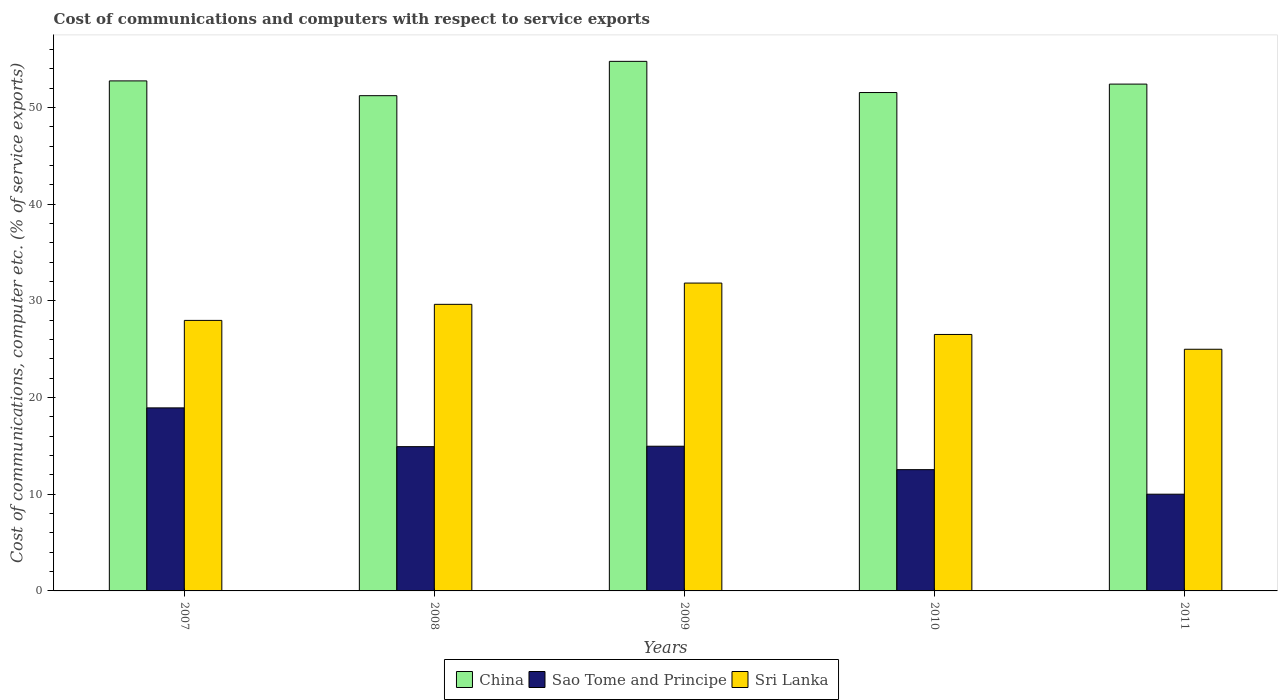How many groups of bars are there?
Your response must be concise. 5. What is the cost of communications and computers in China in 2011?
Offer a very short reply. 52.43. Across all years, what is the maximum cost of communications and computers in Sri Lanka?
Make the answer very short. 31.84. Across all years, what is the minimum cost of communications and computers in Sao Tome and Principe?
Offer a very short reply. 10. In which year was the cost of communications and computers in Sri Lanka minimum?
Your answer should be very brief. 2011. What is the total cost of communications and computers in China in the graph?
Offer a very short reply. 262.74. What is the difference between the cost of communications and computers in Sri Lanka in 2008 and that in 2010?
Provide a succinct answer. 3.12. What is the difference between the cost of communications and computers in Sao Tome and Principe in 2007 and the cost of communications and computers in China in 2008?
Make the answer very short. -32.29. What is the average cost of communications and computers in Sri Lanka per year?
Make the answer very short. 28.2. In the year 2010, what is the difference between the cost of communications and computers in Sri Lanka and cost of communications and computers in Sao Tome and Principe?
Make the answer very short. 13.98. In how many years, is the cost of communications and computers in Sao Tome and Principe greater than 52 %?
Give a very brief answer. 0. What is the ratio of the cost of communications and computers in China in 2009 to that in 2011?
Provide a succinct answer. 1.04. Is the cost of communications and computers in China in 2008 less than that in 2009?
Provide a short and direct response. Yes. What is the difference between the highest and the second highest cost of communications and computers in Sao Tome and Principe?
Give a very brief answer. 3.97. What is the difference between the highest and the lowest cost of communications and computers in Sri Lanka?
Provide a short and direct response. 6.85. In how many years, is the cost of communications and computers in Sri Lanka greater than the average cost of communications and computers in Sri Lanka taken over all years?
Give a very brief answer. 2. Is the sum of the cost of communications and computers in China in 2007 and 2009 greater than the maximum cost of communications and computers in Sri Lanka across all years?
Your response must be concise. Yes. What does the 3rd bar from the left in 2010 represents?
Keep it short and to the point. Sri Lanka. What does the 2nd bar from the right in 2009 represents?
Your answer should be very brief. Sao Tome and Principe. How many bars are there?
Make the answer very short. 15. Are the values on the major ticks of Y-axis written in scientific E-notation?
Make the answer very short. No. What is the title of the graph?
Your response must be concise. Cost of communications and computers with respect to service exports. Does "Argentina" appear as one of the legend labels in the graph?
Make the answer very short. No. What is the label or title of the X-axis?
Keep it short and to the point. Years. What is the label or title of the Y-axis?
Provide a succinct answer. Cost of communications, computer etc. (% of service exports). What is the Cost of communications, computer etc. (% of service exports) of China in 2007?
Provide a succinct answer. 52.76. What is the Cost of communications, computer etc. (% of service exports) in Sao Tome and Principe in 2007?
Make the answer very short. 18.93. What is the Cost of communications, computer etc. (% of service exports) in Sri Lanka in 2007?
Your answer should be very brief. 27.98. What is the Cost of communications, computer etc. (% of service exports) in China in 2008?
Make the answer very short. 51.23. What is the Cost of communications, computer etc. (% of service exports) in Sao Tome and Principe in 2008?
Provide a short and direct response. 14.92. What is the Cost of communications, computer etc. (% of service exports) in Sri Lanka in 2008?
Offer a very short reply. 29.64. What is the Cost of communications, computer etc. (% of service exports) in China in 2009?
Keep it short and to the point. 54.78. What is the Cost of communications, computer etc. (% of service exports) of Sao Tome and Principe in 2009?
Provide a short and direct response. 14.97. What is the Cost of communications, computer etc. (% of service exports) of Sri Lanka in 2009?
Your response must be concise. 31.84. What is the Cost of communications, computer etc. (% of service exports) in China in 2010?
Offer a very short reply. 51.55. What is the Cost of communications, computer etc. (% of service exports) of Sao Tome and Principe in 2010?
Offer a very short reply. 12.54. What is the Cost of communications, computer etc. (% of service exports) of Sri Lanka in 2010?
Make the answer very short. 26.53. What is the Cost of communications, computer etc. (% of service exports) of China in 2011?
Give a very brief answer. 52.43. What is the Cost of communications, computer etc. (% of service exports) of Sao Tome and Principe in 2011?
Ensure brevity in your answer.  10. What is the Cost of communications, computer etc. (% of service exports) of Sri Lanka in 2011?
Your answer should be compact. 25. Across all years, what is the maximum Cost of communications, computer etc. (% of service exports) of China?
Your answer should be very brief. 54.78. Across all years, what is the maximum Cost of communications, computer etc. (% of service exports) in Sao Tome and Principe?
Keep it short and to the point. 18.93. Across all years, what is the maximum Cost of communications, computer etc. (% of service exports) of Sri Lanka?
Offer a terse response. 31.84. Across all years, what is the minimum Cost of communications, computer etc. (% of service exports) of China?
Offer a terse response. 51.23. Across all years, what is the minimum Cost of communications, computer etc. (% of service exports) of Sao Tome and Principe?
Provide a short and direct response. 10. Across all years, what is the minimum Cost of communications, computer etc. (% of service exports) in Sri Lanka?
Provide a succinct answer. 25. What is the total Cost of communications, computer etc. (% of service exports) of China in the graph?
Offer a very short reply. 262.74. What is the total Cost of communications, computer etc. (% of service exports) of Sao Tome and Principe in the graph?
Offer a terse response. 71.37. What is the total Cost of communications, computer etc. (% of service exports) of Sri Lanka in the graph?
Offer a very short reply. 141. What is the difference between the Cost of communications, computer etc. (% of service exports) in China in 2007 and that in 2008?
Your answer should be very brief. 1.53. What is the difference between the Cost of communications, computer etc. (% of service exports) of Sao Tome and Principe in 2007 and that in 2008?
Keep it short and to the point. 4.01. What is the difference between the Cost of communications, computer etc. (% of service exports) of Sri Lanka in 2007 and that in 2008?
Make the answer very short. -1.66. What is the difference between the Cost of communications, computer etc. (% of service exports) in China in 2007 and that in 2009?
Your answer should be very brief. -2.02. What is the difference between the Cost of communications, computer etc. (% of service exports) of Sao Tome and Principe in 2007 and that in 2009?
Your answer should be very brief. 3.97. What is the difference between the Cost of communications, computer etc. (% of service exports) in Sri Lanka in 2007 and that in 2009?
Offer a terse response. -3.86. What is the difference between the Cost of communications, computer etc. (% of service exports) in China in 2007 and that in 2010?
Your response must be concise. 1.2. What is the difference between the Cost of communications, computer etc. (% of service exports) of Sao Tome and Principe in 2007 and that in 2010?
Keep it short and to the point. 6.39. What is the difference between the Cost of communications, computer etc. (% of service exports) of Sri Lanka in 2007 and that in 2010?
Give a very brief answer. 1.46. What is the difference between the Cost of communications, computer etc. (% of service exports) of China in 2007 and that in 2011?
Offer a terse response. 0.33. What is the difference between the Cost of communications, computer etc. (% of service exports) of Sao Tome and Principe in 2007 and that in 2011?
Provide a short and direct response. 8.93. What is the difference between the Cost of communications, computer etc. (% of service exports) of Sri Lanka in 2007 and that in 2011?
Make the answer very short. 2.99. What is the difference between the Cost of communications, computer etc. (% of service exports) of China in 2008 and that in 2009?
Offer a very short reply. -3.55. What is the difference between the Cost of communications, computer etc. (% of service exports) of Sao Tome and Principe in 2008 and that in 2009?
Give a very brief answer. -0.04. What is the difference between the Cost of communications, computer etc. (% of service exports) in Sri Lanka in 2008 and that in 2009?
Make the answer very short. -2.2. What is the difference between the Cost of communications, computer etc. (% of service exports) of China in 2008 and that in 2010?
Offer a terse response. -0.33. What is the difference between the Cost of communications, computer etc. (% of service exports) in Sao Tome and Principe in 2008 and that in 2010?
Keep it short and to the point. 2.38. What is the difference between the Cost of communications, computer etc. (% of service exports) in Sri Lanka in 2008 and that in 2010?
Give a very brief answer. 3.12. What is the difference between the Cost of communications, computer etc. (% of service exports) in China in 2008 and that in 2011?
Make the answer very short. -1.2. What is the difference between the Cost of communications, computer etc. (% of service exports) of Sao Tome and Principe in 2008 and that in 2011?
Your answer should be very brief. 4.92. What is the difference between the Cost of communications, computer etc. (% of service exports) in Sri Lanka in 2008 and that in 2011?
Provide a short and direct response. 4.65. What is the difference between the Cost of communications, computer etc. (% of service exports) of China in 2009 and that in 2010?
Ensure brevity in your answer.  3.23. What is the difference between the Cost of communications, computer etc. (% of service exports) of Sao Tome and Principe in 2009 and that in 2010?
Your answer should be compact. 2.42. What is the difference between the Cost of communications, computer etc. (% of service exports) in Sri Lanka in 2009 and that in 2010?
Keep it short and to the point. 5.32. What is the difference between the Cost of communications, computer etc. (% of service exports) of China in 2009 and that in 2011?
Provide a succinct answer. 2.35. What is the difference between the Cost of communications, computer etc. (% of service exports) of Sao Tome and Principe in 2009 and that in 2011?
Provide a succinct answer. 4.96. What is the difference between the Cost of communications, computer etc. (% of service exports) of Sri Lanka in 2009 and that in 2011?
Your answer should be very brief. 6.85. What is the difference between the Cost of communications, computer etc. (% of service exports) of China in 2010 and that in 2011?
Give a very brief answer. -0.87. What is the difference between the Cost of communications, computer etc. (% of service exports) of Sao Tome and Principe in 2010 and that in 2011?
Ensure brevity in your answer.  2.54. What is the difference between the Cost of communications, computer etc. (% of service exports) of Sri Lanka in 2010 and that in 2011?
Your answer should be compact. 1.53. What is the difference between the Cost of communications, computer etc. (% of service exports) of China in 2007 and the Cost of communications, computer etc. (% of service exports) of Sao Tome and Principe in 2008?
Offer a terse response. 37.83. What is the difference between the Cost of communications, computer etc. (% of service exports) in China in 2007 and the Cost of communications, computer etc. (% of service exports) in Sri Lanka in 2008?
Your response must be concise. 23.11. What is the difference between the Cost of communications, computer etc. (% of service exports) of Sao Tome and Principe in 2007 and the Cost of communications, computer etc. (% of service exports) of Sri Lanka in 2008?
Ensure brevity in your answer.  -10.71. What is the difference between the Cost of communications, computer etc. (% of service exports) of China in 2007 and the Cost of communications, computer etc. (% of service exports) of Sao Tome and Principe in 2009?
Your answer should be very brief. 37.79. What is the difference between the Cost of communications, computer etc. (% of service exports) in China in 2007 and the Cost of communications, computer etc. (% of service exports) in Sri Lanka in 2009?
Provide a succinct answer. 20.91. What is the difference between the Cost of communications, computer etc. (% of service exports) in Sao Tome and Principe in 2007 and the Cost of communications, computer etc. (% of service exports) in Sri Lanka in 2009?
Make the answer very short. -12.91. What is the difference between the Cost of communications, computer etc. (% of service exports) in China in 2007 and the Cost of communications, computer etc. (% of service exports) in Sao Tome and Principe in 2010?
Give a very brief answer. 40.21. What is the difference between the Cost of communications, computer etc. (% of service exports) of China in 2007 and the Cost of communications, computer etc. (% of service exports) of Sri Lanka in 2010?
Offer a very short reply. 26.23. What is the difference between the Cost of communications, computer etc. (% of service exports) of Sao Tome and Principe in 2007 and the Cost of communications, computer etc. (% of service exports) of Sri Lanka in 2010?
Keep it short and to the point. -7.59. What is the difference between the Cost of communications, computer etc. (% of service exports) of China in 2007 and the Cost of communications, computer etc. (% of service exports) of Sao Tome and Principe in 2011?
Provide a short and direct response. 42.75. What is the difference between the Cost of communications, computer etc. (% of service exports) of China in 2007 and the Cost of communications, computer etc. (% of service exports) of Sri Lanka in 2011?
Make the answer very short. 27.76. What is the difference between the Cost of communications, computer etc. (% of service exports) of Sao Tome and Principe in 2007 and the Cost of communications, computer etc. (% of service exports) of Sri Lanka in 2011?
Your answer should be very brief. -6.06. What is the difference between the Cost of communications, computer etc. (% of service exports) of China in 2008 and the Cost of communications, computer etc. (% of service exports) of Sao Tome and Principe in 2009?
Keep it short and to the point. 36.26. What is the difference between the Cost of communications, computer etc. (% of service exports) of China in 2008 and the Cost of communications, computer etc. (% of service exports) of Sri Lanka in 2009?
Offer a terse response. 19.38. What is the difference between the Cost of communications, computer etc. (% of service exports) of Sao Tome and Principe in 2008 and the Cost of communications, computer etc. (% of service exports) of Sri Lanka in 2009?
Keep it short and to the point. -16.92. What is the difference between the Cost of communications, computer etc. (% of service exports) of China in 2008 and the Cost of communications, computer etc. (% of service exports) of Sao Tome and Principe in 2010?
Your response must be concise. 38.68. What is the difference between the Cost of communications, computer etc. (% of service exports) of China in 2008 and the Cost of communications, computer etc. (% of service exports) of Sri Lanka in 2010?
Ensure brevity in your answer.  24.7. What is the difference between the Cost of communications, computer etc. (% of service exports) of Sao Tome and Principe in 2008 and the Cost of communications, computer etc. (% of service exports) of Sri Lanka in 2010?
Provide a succinct answer. -11.6. What is the difference between the Cost of communications, computer etc. (% of service exports) of China in 2008 and the Cost of communications, computer etc. (% of service exports) of Sao Tome and Principe in 2011?
Give a very brief answer. 41.22. What is the difference between the Cost of communications, computer etc. (% of service exports) in China in 2008 and the Cost of communications, computer etc. (% of service exports) in Sri Lanka in 2011?
Offer a very short reply. 26.23. What is the difference between the Cost of communications, computer etc. (% of service exports) of Sao Tome and Principe in 2008 and the Cost of communications, computer etc. (% of service exports) of Sri Lanka in 2011?
Provide a succinct answer. -10.07. What is the difference between the Cost of communications, computer etc. (% of service exports) of China in 2009 and the Cost of communications, computer etc. (% of service exports) of Sao Tome and Principe in 2010?
Make the answer very short. 42.23. What is the difference between the Cost of communications, computer etc. (% of service exports) in China in 2009 and the Cost of communications, computer etc. (% of service exports) in Sri Lanka in 2010?
Your response must be concise. 28.25. What is the difference between the Cost of communications, computer etc. (% of service exports) in Sao Tome and Principe in 2009 and the Cost of communications, computer etc. (% of service exports) in Sri Lanka in 2010?
Keep it short and to the point. -11.56. What is the difference between the Cost of communications, computer etc. (% of service exports) in China in 2009 and the Cost of communications, computer etc. (% of service exports) in Sao Tome and Principe in 2011?
Your answer should be very brief. 44.77. What is the difference between the Cost of communications, computer etc. (% of service exports) in China in 2009 and the Cost of communications, computer etc. (% of service exports) in Sri Lanka in 2011?
Offer a very short reply. 29.78. What is the difference between the Cost of communications, computer etc. (% of service exports) in Sao Tome and Principe in 2009 and the Cost of communications, computer etc. (% of service exports) in Sri Lanka in 2011?
Ensure brevity in your answer.  -10.03. What is the difference between the Cost of communications, computer etc. (% of service exports) of China in 2010 and the Cost of communications, computer etc. (% of service exports) of Sao Tome and Principe in 2011?
Ensure brevity in your answer.  41.55. What is the difference between the Cost of communications, computer etc. (% of service exports) in China in 2010 and the Cost of communications, computer etc. (% of service exports) in Sri Lanka in 2011?
Provide a succinct answer. 26.55. What is the difference between the Cost of communications, computer etc. (% of service exports) in Sao Tome and Principe in 2010 and the Cost of communications, computer etc. (% of service exports) in Sri Lanka in 2011?
Ensure brevity in your answer.  -12.45. What is the average Cost of communications, computer etc. (% of service exports) in China per year?
Provide a succinct answer. 52.55. What is the average Cost of communications, computer etc. (% of service exports) of Sao Tome and Principe per year?
Make the answer very short. 14.27. What is the average Cost of communications, computer etc. (% of service exports) in Sri Lanka per year?
Keep it short and to the point. 28.2. In the year 2007, what is the difference between the Cost of communications, computer etc. (% of service exports) of China and Cost of communications, computer etc. (% of service exports) of Sao Tome and Principe?
Offer a very short reply. 33.82. In the year 2007, what is the difference between the Cost of communications, computer etc. (% of service exports) of China and Cost of communications, computer etc. (% of service exports) of Sri Lanka?
Your answer should be very brief. 24.77. In the year 2007, what is the difference between the Cost of communications, computer etc. (% of service exports) in Sao Tome and Principe and Cost of communications, computer etc. (% of service exports) in Sri Lanka?
Your answer should be compact. -9.05. In the year 2008, what is the difference between the Cost of communications, computer etc. (% of service exports) of China and Cost of communications, computer etc. (% of service exports) of Sao Tome and Principe?
Your answer should be compact. 36.3. In the year 2008, what is the difference between the Cost of communications, computer etc. (% of service exports) of China and Cost of communications, computer etc. (% of service exports) of Sri Lanka?
Keep it short and to the point. 21.58. In the year 2008, what is the difference between the Cost of communications, computer etc. (% of service exports) of Sao Tome and Principe and Cost of communications, computer etc. (% of service exports) of Sri Lanka?
Keep it short and to the point. -14.72. In the year 2009, what is the difference between the Cost of communications, computer etc. (% of service exports) of China and Cost of communications, computer etc. (% of service exports) of Sao Tome and Principe?
Your answer should be very brief. 39.81. In the year 2009, what is the difference between the Cost of communications, computer etc. (% of service exports) in China and Cost of communications, computer etc. (% of service exports) in Sri Lanka?
Keep it short and to the point. 22.93. In the year 2009, what is the difference between the Cost of communications, computer etc. (% of service exports) in Sao Tome and Principe and Cost of communications, computer etc. (% of service exports) in Sri Lanka?
Offer a very short reply. -16.88. In the year 2010, what is the difference between the Cost of communications, computer etc. (% of service exports) of China and Cost of communications, computer etc. (% of service exports) of Sao Tome and Principe?
Provide a succinct answer. 39.01. In the year 2010, what is the difference between the Cost of communications, computer etc. (% of service exports) in China and Cost of communications, computer etc. (% of service exports) in Sri Lanka?
Make the answer very short. 25.03. In the year 2010, what is the difference between the Cost of communications, computer etc. (% of service exports) in Sao Tome and Principe and Cost of communications, computer etc. (% of service exports) in Sri Lanka?
Ensure brevity in your answer.  -13.98. In the year 2011, what is the difference between the Cost of communications, computer etc. (% of service exports) in China and Cost of communications, computer etc. (% of service exports) in Sao Tome and Principe?
Offer a very short reply. 42.42. In the year 2011, what is the difference between the Cost of communications, computer etc. (% of service exports) of China and Cost of communications, computer etc. (% of service exports) of Sri Lanka?
Give a very brief answer. 27.43. In the year 2011, what is the difference between the Cost of communications, computer etc. (% of service exports) in Sao Tome and Principe and Cost of communications, computer etc. (% of service exports) in Sri Lanka?
Your answer should be very brief. -14.99. What is the ratio of the Cost of communications, computer etc. (% of service exports) in China in 2007 to that in 2008?
Your answer should be compact. 1.03. What is the ratio of the Cost of communications, computer etc. (% of service exports) in Sao Tome and Principe in 2007 to that in 2008?
Keep it short and to the point. 1.27. What is the ratio of the Cost of communications, computer etc. (% of service exports) of Sri Lanka in 2007 to that in 2008?
Provide a succinct answer. 0.94. What is the ratio of the Cost of communications, computer etc. (% of service exports) of China in 2007 to that in 2009?
Provide a short and direct response. 0.96. What is the ratio of the Cost of communications, computer etc. (% of service exports) in Sao Tome and Principe in 2007 to that in 2009?
Provide a succinct answer. 1.26. What is the ratio of the Cost of communications, computer etc. (% of service exports) in Sri Lanka in 2007 to that in 2009?
Ensure brevity in your answer.  0.88. What is the ratio of the Cost of communications, computer etc. (% of service exports) of China in 2007 to that in 2010?
Provide a short and direct response. 1.02. What is the ratio of the Cost of communications, computer etc. (% of service exports) of Sao Tome and Principe in 2007 to that in 2010?
Ensure brevity in your answer.  1.51. What is the ratio of the Cost of communications, computer etc. (% of service exports) in Sri Lanka in 2007 to that in 2010?
Provide a succinct answer. 1.05. What is the ratio of the Cost of communications, computer etc. (% of service exports) of China in 2007 to that in 2011?
Offer a very short reply. 1.01. What is the ratio of the Cost of communications, computer etc. (% of service exports) in Sao Tome and Principe in 2007 to that in 2011?
Your answer should be very brief. 1.89. What is the ratio of the Cost of communications, computer etc. (% of service exports) in Sri Lanka in 2007 to that in 2011?
Make the answer very short. 1.12. What is the ratio of the Cost of communications, computer etc. (% of service exports) in China in 2008 to that in 2009?
Your response must be concise. 0.94. What is the ratio of the Cost of communications, computer etc. (% of service exports) of Sao Tome and Principe in 2008 to that in 2009?
Provide a short and direct response. 1. What is the ratio of the Cost of communications, computer etc. (% of service exports) in Sri Lanka in 2008 to that in 2009?
Offer a terse response. 0.93. What is the ratio of the Cost of communications, computer etc. (% of service exports) in China in 2008 to that in 2010?
Offer a terse response. 0.99. What is the ratio of the Cost of communications, computer etc. (% of service exports) in Sao Tome and Principe in 2008 to that in 2010?
Provide a short and direct response. 1.19. What is the ratio of the Cost of communications, computer etc. (% of service exports) in Sri Lanka in 2008 to that in 2010?
Your answer should be very brief. 1.12. What is the ratio of the Cost of communications, computer etc. (% of service exports) of China in 2008 to that in 2011?
Provide a succinct answer. 0.98. What is the ratio of the Cost of communications, computer etc. (% of service exports) of Sao Tome and Principe in 2008 to that in 2011?
Provide a short and direct response. 1.49. What is the ratio of the Cost of communications, computer etc. (% of service exports) of Sri Lanka in 2008 to that in 2011?
Offer a very short reply. 1.19. What is the ratio of the Cost of communications, computer etc. (% of service exports) in China in 2009 to that in 2010?
Your response must be concise. 1.06. What is the ratio of the Cost of communications, computer etc. (% of service exports) of Sao Tome and Principe in 2009 to that in 2010?
Ensure brevity in your answer.  1.19. What is the ratio of the Cost of communications, computer etc. (% of service exports) of Sri Lanka in 2009 to that in 2010?
Offer a terse response. 1.2. What is the ratio of the Cost of communications, computer etc. (% of service exports) in China in 2009 to that in 2011?
Your response must be concise. 1.04. What is the ratio of the Cost of communications, computer etc. (% of service exports) of Sao Tome and Principe in 2009 to that in 2011?
Offer a terse response. 1.5. What is the ratio of the Cost of communications, computer etc. (% of service exports) of Sri Lanka in 2009 to that in 2011?
Your response must be concise. 1.27. What is the ratio of the Cost of communications, computer etc. (% of service exports) of China in 2010 to that in 2011?
Your answer should be very brief. 0.98. What is the ratio of the Cost of communications, computer etc. (% of service exports) of Sao Tome and Principe in 2010 to that in 2011?
Give a very brief answer. 1.25. What is the ratio of the Cost of communications, computer etc. (% of service exports) in Sri Lanka in 2010 to that in 2011?
Make the answer very short. 1.06. What is the difference between the highest and the second highest Cost of communications, computer etc. (% of service exports) in China?
Offer a terse response. 2.02. What is the difference between the highest and the second highest Cost of communications, computer etc. (% of service exports) in Sao Tome and Principe?
Your answer should be compact. 3.97. What is the difference between the highest and the second highest Cost of communications, computer etc. (% of service exports) in Sri Lanka?
Your answer should be very brief. 2.2. What is the difference between the highest and the lowest Cost of communications, computer etc. (% of service exports) in China?
Your answer should be compact. 3.55. What is the difference between the highest and the lowest Cost of communications, computer etc. (% of service exports) in Sao Tome and Principe?
Make the answer very short. 8.93. What is the difference between the highest and the lowest Cost of communications, computer etc. (% of service exports) of Sri Lanka?
Keep it short and to the point. 6.85. 